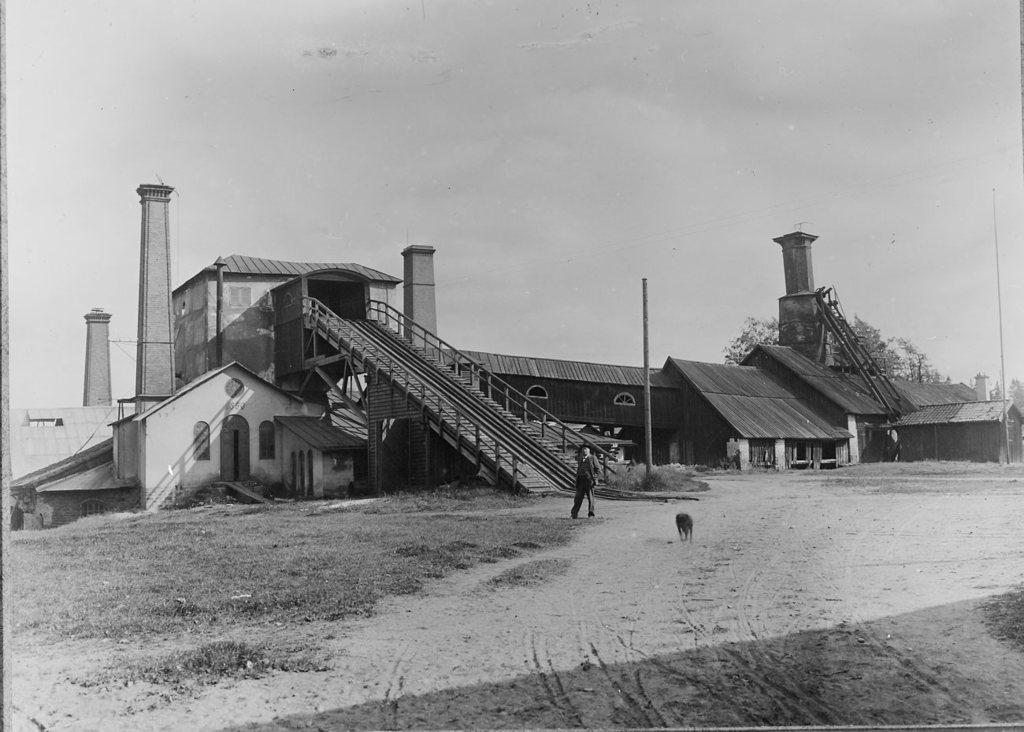What type of location is depicted in the image? The image appears to depict a factory. What type of terrain is visible in the image? There is sand in the image. Can you describe the people in the image? There is a man in the image. Are there any animals present in the image? Yes, there is an animal in the image. What type of vegetation is on the right side of the image? There are trees on the right side of the image. What is visible in the sky in the image? The sky is visible in the image. What language is the man speaking to the crook in the image? There is no crook present in the image, and the man's speech cannot be determined from the image. How many cacti are visible in the image? There are no cacti present in the image. 